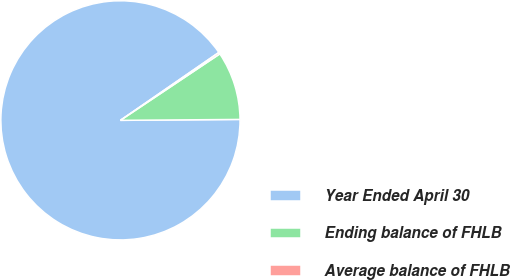Convert chart to OTSL. <chart><loc_0><loc_0><loc_500><loc_500><pie_chart><fcel>Year Ended April 30<fcel>Ending balance of FHLB<fcel>Average balance of FHLB<nl><fcel>90.51%<fcel>9.26%<fcel>0.23%<nl></chart> 